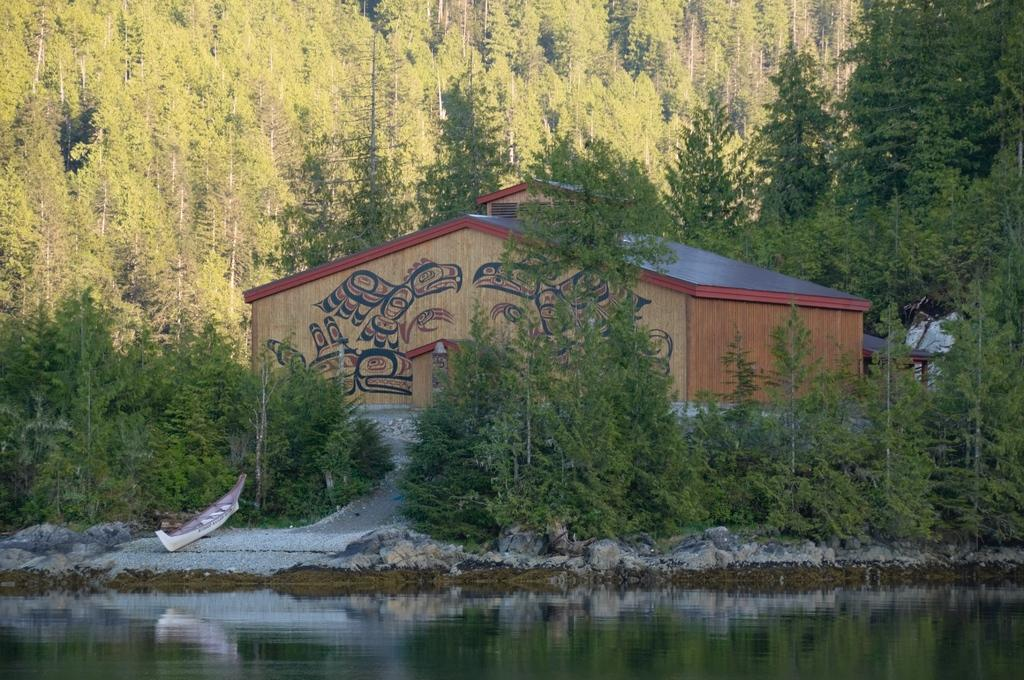What type of structure is present in the image? There is a building in the image. What natural elements can be seen in the image? A: There are trees, plants, and grass visible in the image. Is there any indication of water in the image? Yes, there is water flow visible at the bottom of the image. What type of silk fabric is draped over the throne in the image? There is no throne or silk fabric present in the image. What type of basin is used for water collection in the image? There is no basin present in the image; the water flow is visible at the bottom without any specific collection device. 